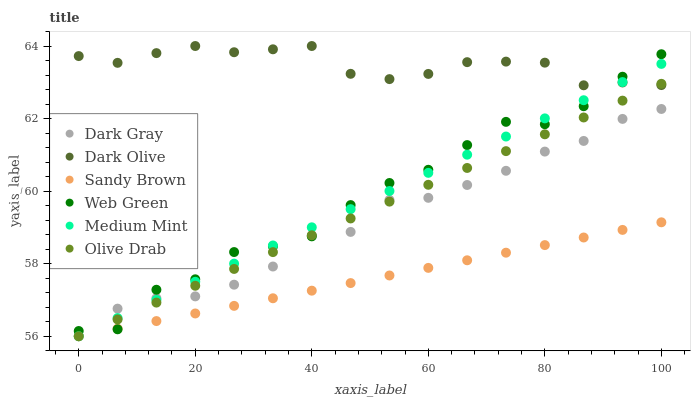Does Sandy Brown have the minimum area under the curve?
Answer yes or no. Yes. Does Dark Olive have the maximum area under the curve?
Answer yes or no. Yes. Does Web Green have the minimum area under the curve?
Answer yes or no. No. Does Web Green have the maximum area under the curve?
Answer yes or no. No. Is Olive Drab the smoothest?
Answer yes or no. Yes. Is Web Green the roughest?
Answer yes or no. Yes. Is Dark Olive the smoothest?
Answer yes or no. No. Is Dark Olive the roughest?
Answer yes or no. No. Does Medium Mint have the lowest value?
Answer yes or no. Yes. Does Web Green have the lowest value?
Answer yes or no. No. Does Dark Olive have the highest value?
Answer yes or no. Yes. Does Web Green have the highest value?
Answer yes or no. No. Is Sandy Brown less than Dark Olive?
Answer yes or no. Yes. Is Dark Olive greater than Dark Gray?
Answer yes or no. Yes. Does Medium Mint intersect Olive Drab?
Answer yes or no. Yes. Is Medium Mint less than Olive Drab?
Answer yes or no. No. Is Medium Mint greater than Olive Drab?
Answer yes or no. No. Does Sandy Brown intersect Dark Olive?
Answer yes or no. No. 